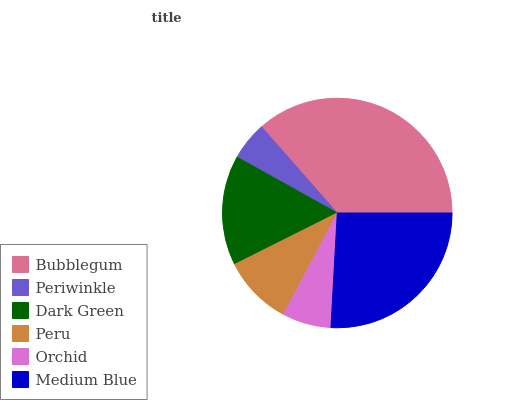Is Periwinkle the minimum?
Answer yes or no. Yes. Is Bubblegum the maximum?
Answer yes or no. Yes. Is Dark Green the minimum?
Answer yes or no. No. Is Dark Green the maximum?
Answer yes or no. No. Is Dark Green greater than Periwinkle?
Answer yes or no. Yes. Is Periwinkle less than Dark Green?
Answer yes or no. Yes. Is Periwinkle greater than Dark Green?
Answer yes or no. No. Is Dark Green less than Periwinkle?
Answer yes or no. No. Is Dark Green the high median?
Answer yes or no. Yes. Is Peru the low median?
Answer yes or no. Yes. Is Periwinkle the high median?
Answer yes or no. No. Is Bubblegum the low median?
Answer yes or no. No. 